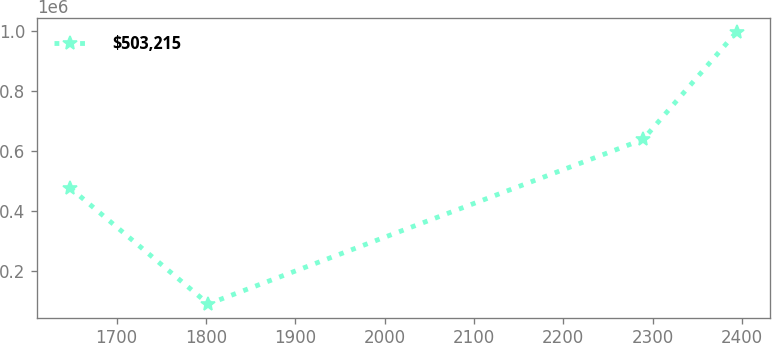Convert chart to OTSL. <chart><loc_0><loc_0><loc_500><loc_500><line_chart><ecel><fcel>$503,215<nl><fcel>1648.16<fcel>477002<nl><fcel>1802.77<fcel>90533.6<nl><fcel>2289.19<fcel>638533<nl><fcel>2393.95<fcel>996971<nl></chart> 